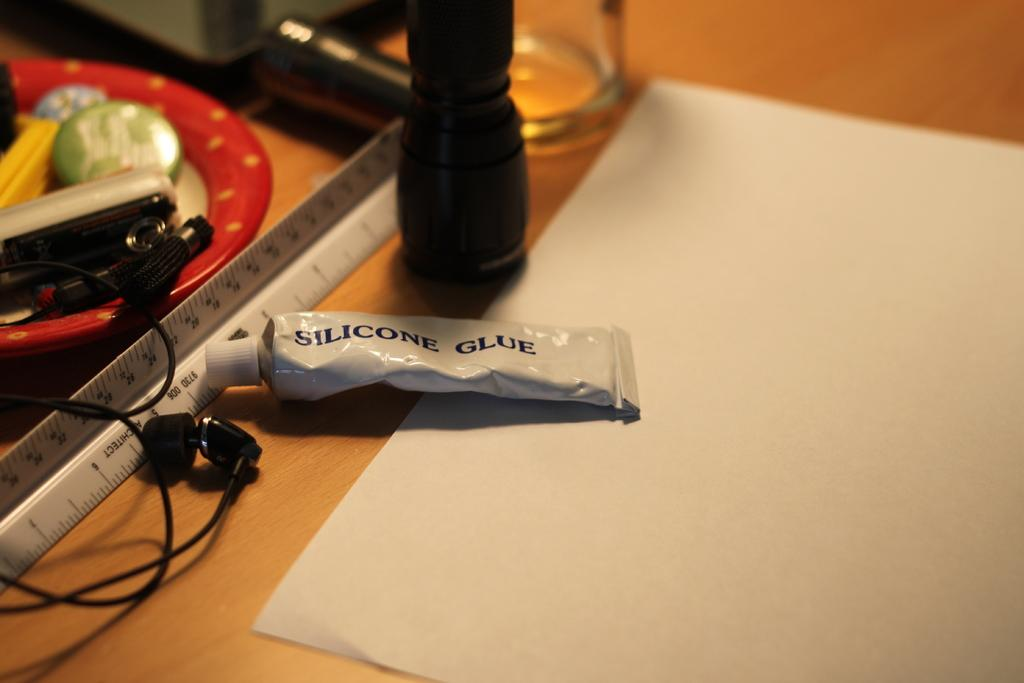What is the primary object in the image? There is a paper in the image. What other objects can be seen in the image? There is a tube, earphones, a glass, a plate, and a measuring scale in the image. Where are these objects located? They are on a wooden platform in the image. What might be used for measuring or weighing in the image? There is a measuring scale in the image for measuring or weighing. What type of silk is being used to cover the earth in the image? There is no silk or reference to the earth in the image; it features a paper and other objects on a wooden platform. 